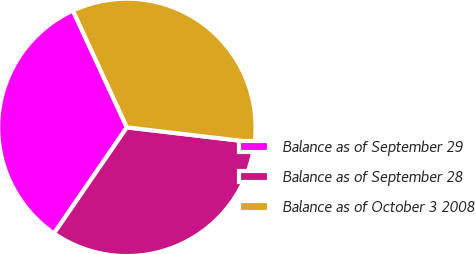Convert chart. <chart><loc_0><loc_0><loc_500><loc_500><pie_chart><fcel>Balance as of September 29<fcel>Balance as of September 28<fcel>Balance as of October 3 2008<nl><fcel>33.53%<fcel>32.72%<fcel>33.75%<nl></chart> 